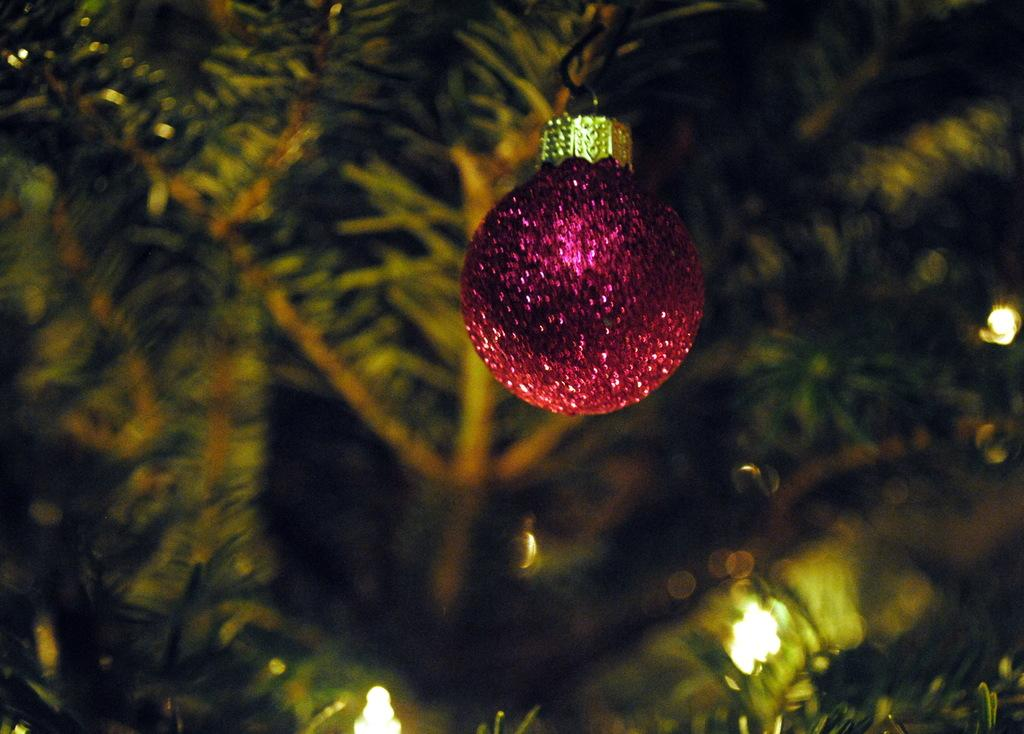What type of object can be seen in the image? There is a decorative object in the image. What color is the decorative object? The decorative object is in violet color. What can be seen in the distance in the image? There are trees and lights in the background of the image. Is there a veil covering the decorative object in the image? No, there is no veil present in the image. What type of school can be seen in the background of the image? There is no school visible in the image; it only features trees and lights in the background. 